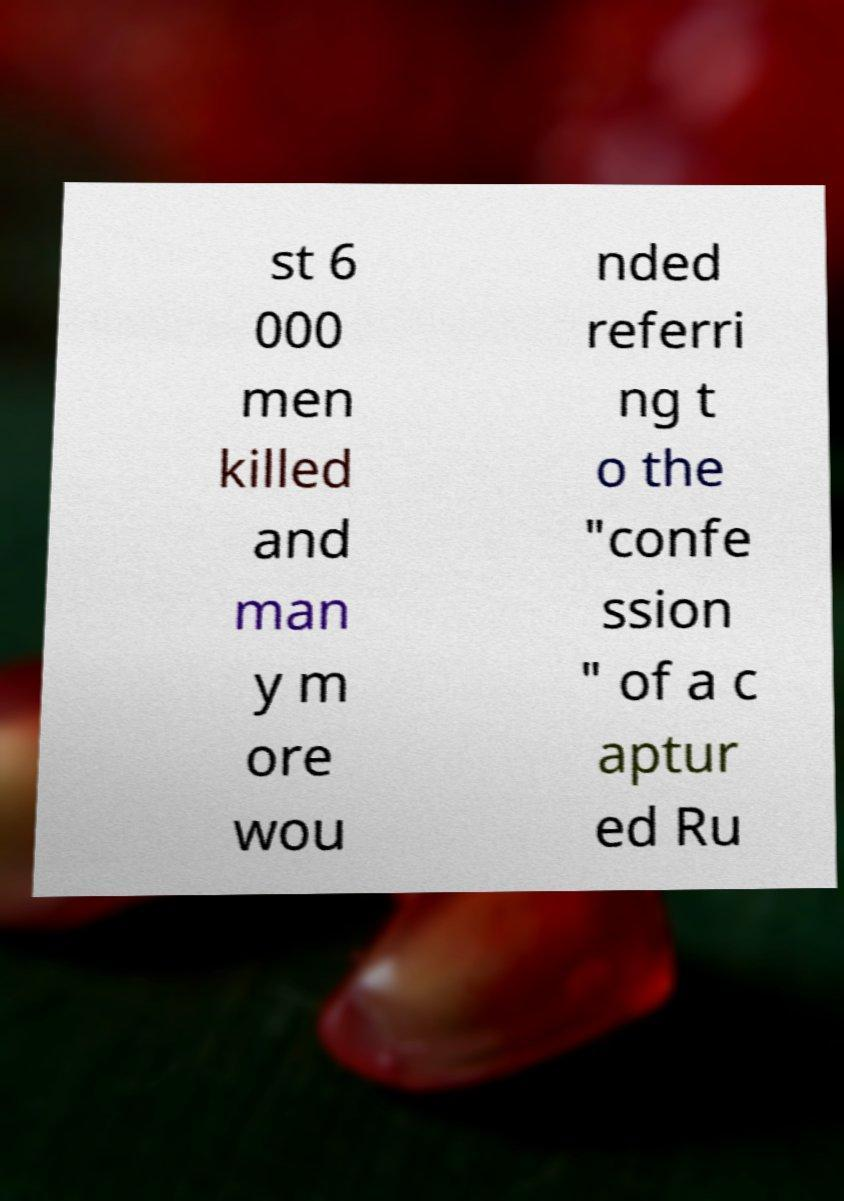Can you read and provide the text displayed in the image?This photo seems to have some interesting text. Can you extract and type it out for me? st 6 000 men killed and man y m ore wou nded referri ng t o the "confe ssion " of a c aptur ed Ru 